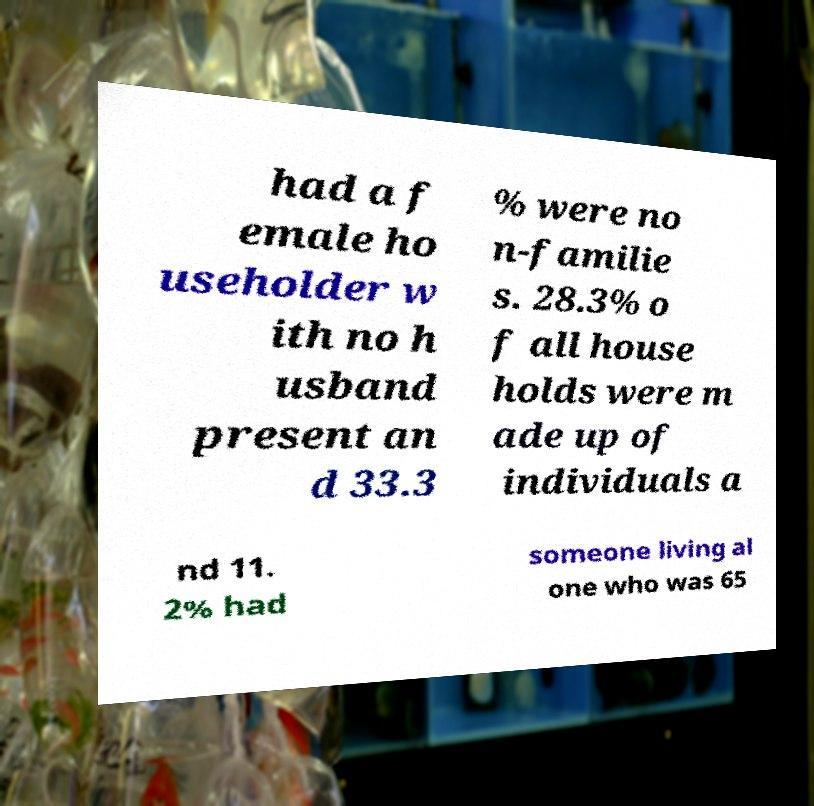Can you accurately transcribe the text from the provided image for me? had a f emale ho useholder w ith no h usband present an d 33.3 % were no n-familie s. 28.3% o f all house holds were m ade up of individuals a nd 11. 2% had someone living al one who was 65 